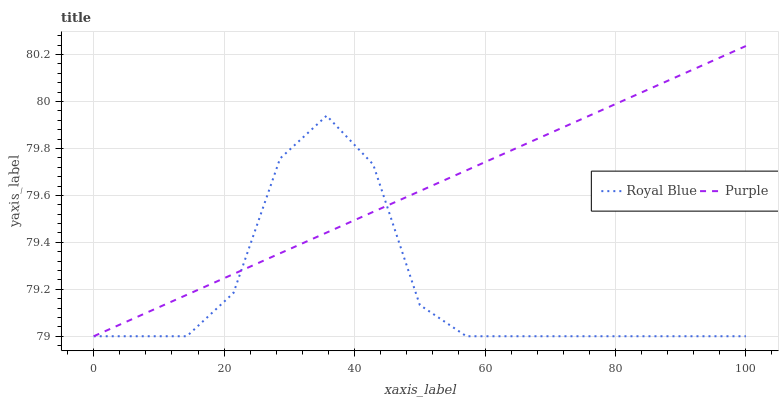Does Royal Blue have the minimum area under the curve?
Answer yes or no. Yes. Does Purple have the maximum area under the curve?
Answer yes or no. Yes. Does Royal Blue have the maximum area under the curve?
Answer yes or no. No. Is Purple the smoothest?
Answer yes or no. Yes. Is Royal Blue the roughest?
Answer yes or no. Yes. Is Royal Blue the smoothest?
Answer yes or no. No. Does Purple have the lowest value?
Answer yes or no. Yes. Does Purple have the highest value?
Answer yes or no. Yes. Does Royal Blue have the highest value?
Answer yes or no. No. Does Royal Blue intersect Purple?
Answer yes or no. Yes. Is Royal Blue less than Purple?
Answer yes or no. No. Is Royal Blue greater than Purple?
Answer yes or no. No. 